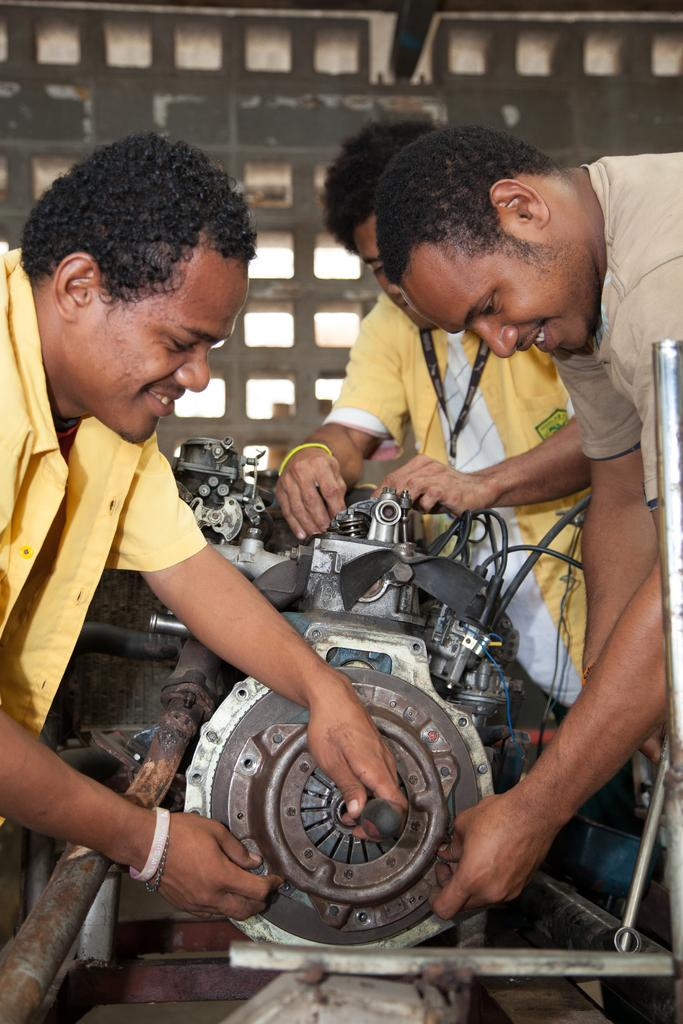How many people are in the image? There are three men in the image. What is the main object in the middle of the image? There is a machine in the middle of the image. What can be seen in the background of the image? There is a wall in the background of the image. What is the rate of the waves in the image? There are no waves present in the image, so it is not possible to determine a rate. 